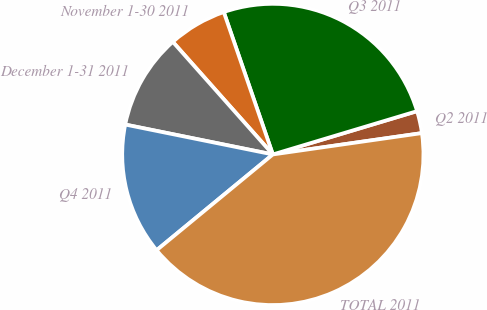Convert chart. <chart><loc_0><loc_0><loc_500><loc_500><pie_chart><fcel>Q2 2011<fcel>Q3 2011<fcel>November 1-30 2011<fcel>December 1-31 2011<fcel>Q4 2011<fcel>TOTAL 2011<nl><fcel>2.38%<fcel>25.64%<fcel>6.28%<fcel>10.26%<fcel>14.15%<fcel>41.3%<nl></chart> 